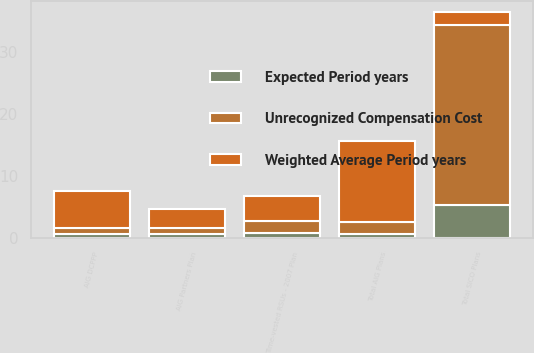<chart> <loc_0><loc_0><loc_500><loc_500><stacked_bar_chart><ecel><fcel>Time-vested RSUs - 2007 Plan<fcel>AIG DCPPP<fcel>AIG Partners Plan<fcel>Total AIG Plans<fcel>Total SICO Plans<nl><fcel>Weighted Average Period years<fcel>4<fcel>6<fcel>3<fcel>13<fcel>2<nl><fcel>Expected Period years<fcel>0.72<fcel>0.63<fcel>0.62<fcel>0.65<fcel>5.39<nl><fcel>Unrecognized Compensation Cost<fcel>2<fcel>1<fcel>1<fcel>2<fcel>29<nl></chart> 